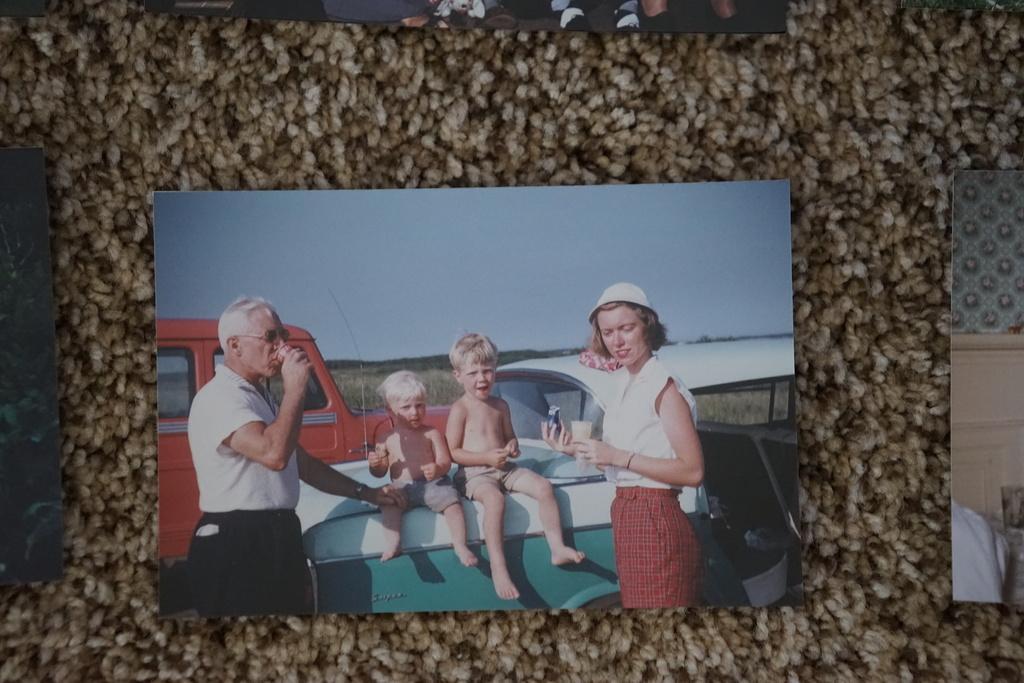How would you summarize this image in a sentence or two? In this image we can see a photocopy, in the photocopy there are few vehicles and persons, two children were sitting on the vehicle and two were standing and having something. 